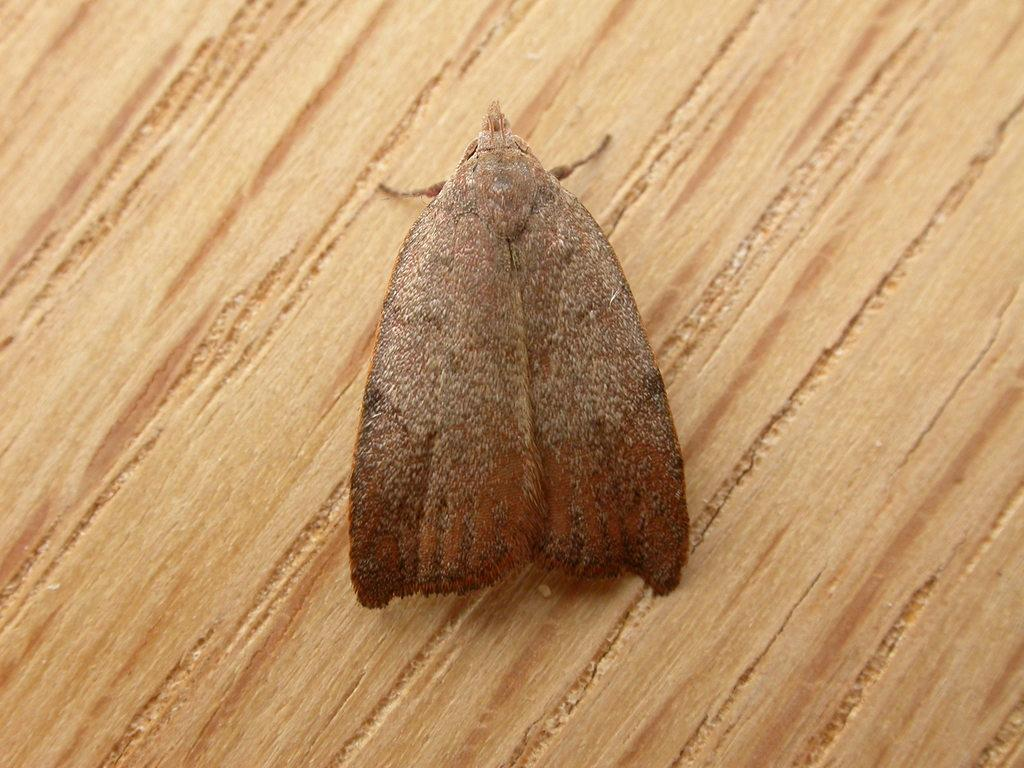What is the color of the surface in the image? The surface in the image is cream-colored. What type of creature can be seen on the surface? There is a brown-colored insect on the surface. Can you see the insect skating on the cream-colored surface in the image? No, there is no skating or any indication of the insect engaging in such activity in the image. 